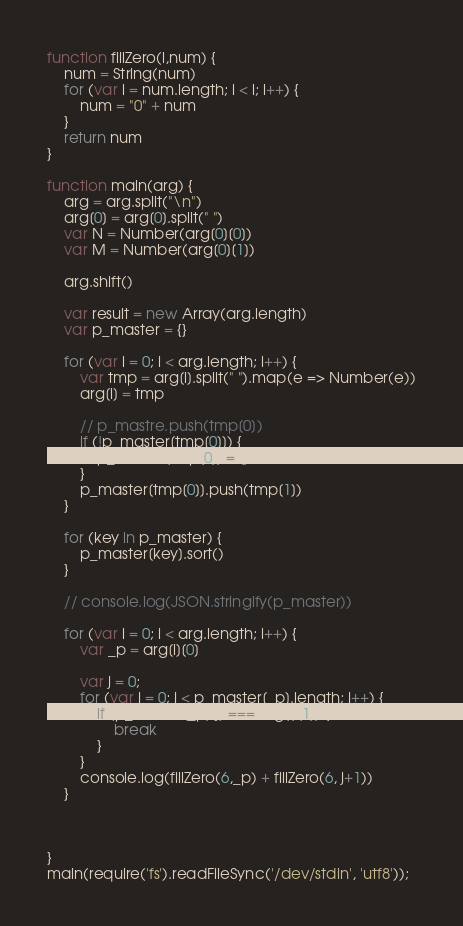Convert code to text. <code><loc_0><loc_0><loc_500><loc_500><_JavaScript_>function fillZero(l,num) {
	num = String(num)
	for (var i = num.length; i < l; i++) {
		num = "0" + num
	}
	return num
}

function main(arg) {
	arg = arg.split("\n")
	arg[0] = arg[0].split(" ")
	var N = Number(arg[0][0])
	var M = Number(arg[0][1])

	arg.shift()

	var result = new Array(arg.length)
	var p_master = {}

	for (var i = 0; i < arg.length; i++) {
		var tmp = arg[i].split(" ").map(e => Number(e))
		arg[i] = tmp

		// p_mastre.push(tmp[0])
		if (!p_master[tmp[0]]) {
			p_master[tmp[0]] = []
		}
		p_master[tmp[0]].push(tmp[1])
	}

	for (key in p_master) {
		p_master[key].sort()
	}

	// console.log(JSON.stringify(p_master))

	for (var i = 0; i < arg.length; i++) {
		var _p = arg[i][0]

		var j = 0;
		for (var j = 0; j < p_master[_p].length; j++) {
			if (p_master[_p][j] === arg[i][1]) {
				break
			}
		}
		console.log(fillZero(6,_p) + fillZero(6, j+1))
	}


	
}
main(require('fs').readFileSync('/dev/stdin', 'utf8'));</code> 